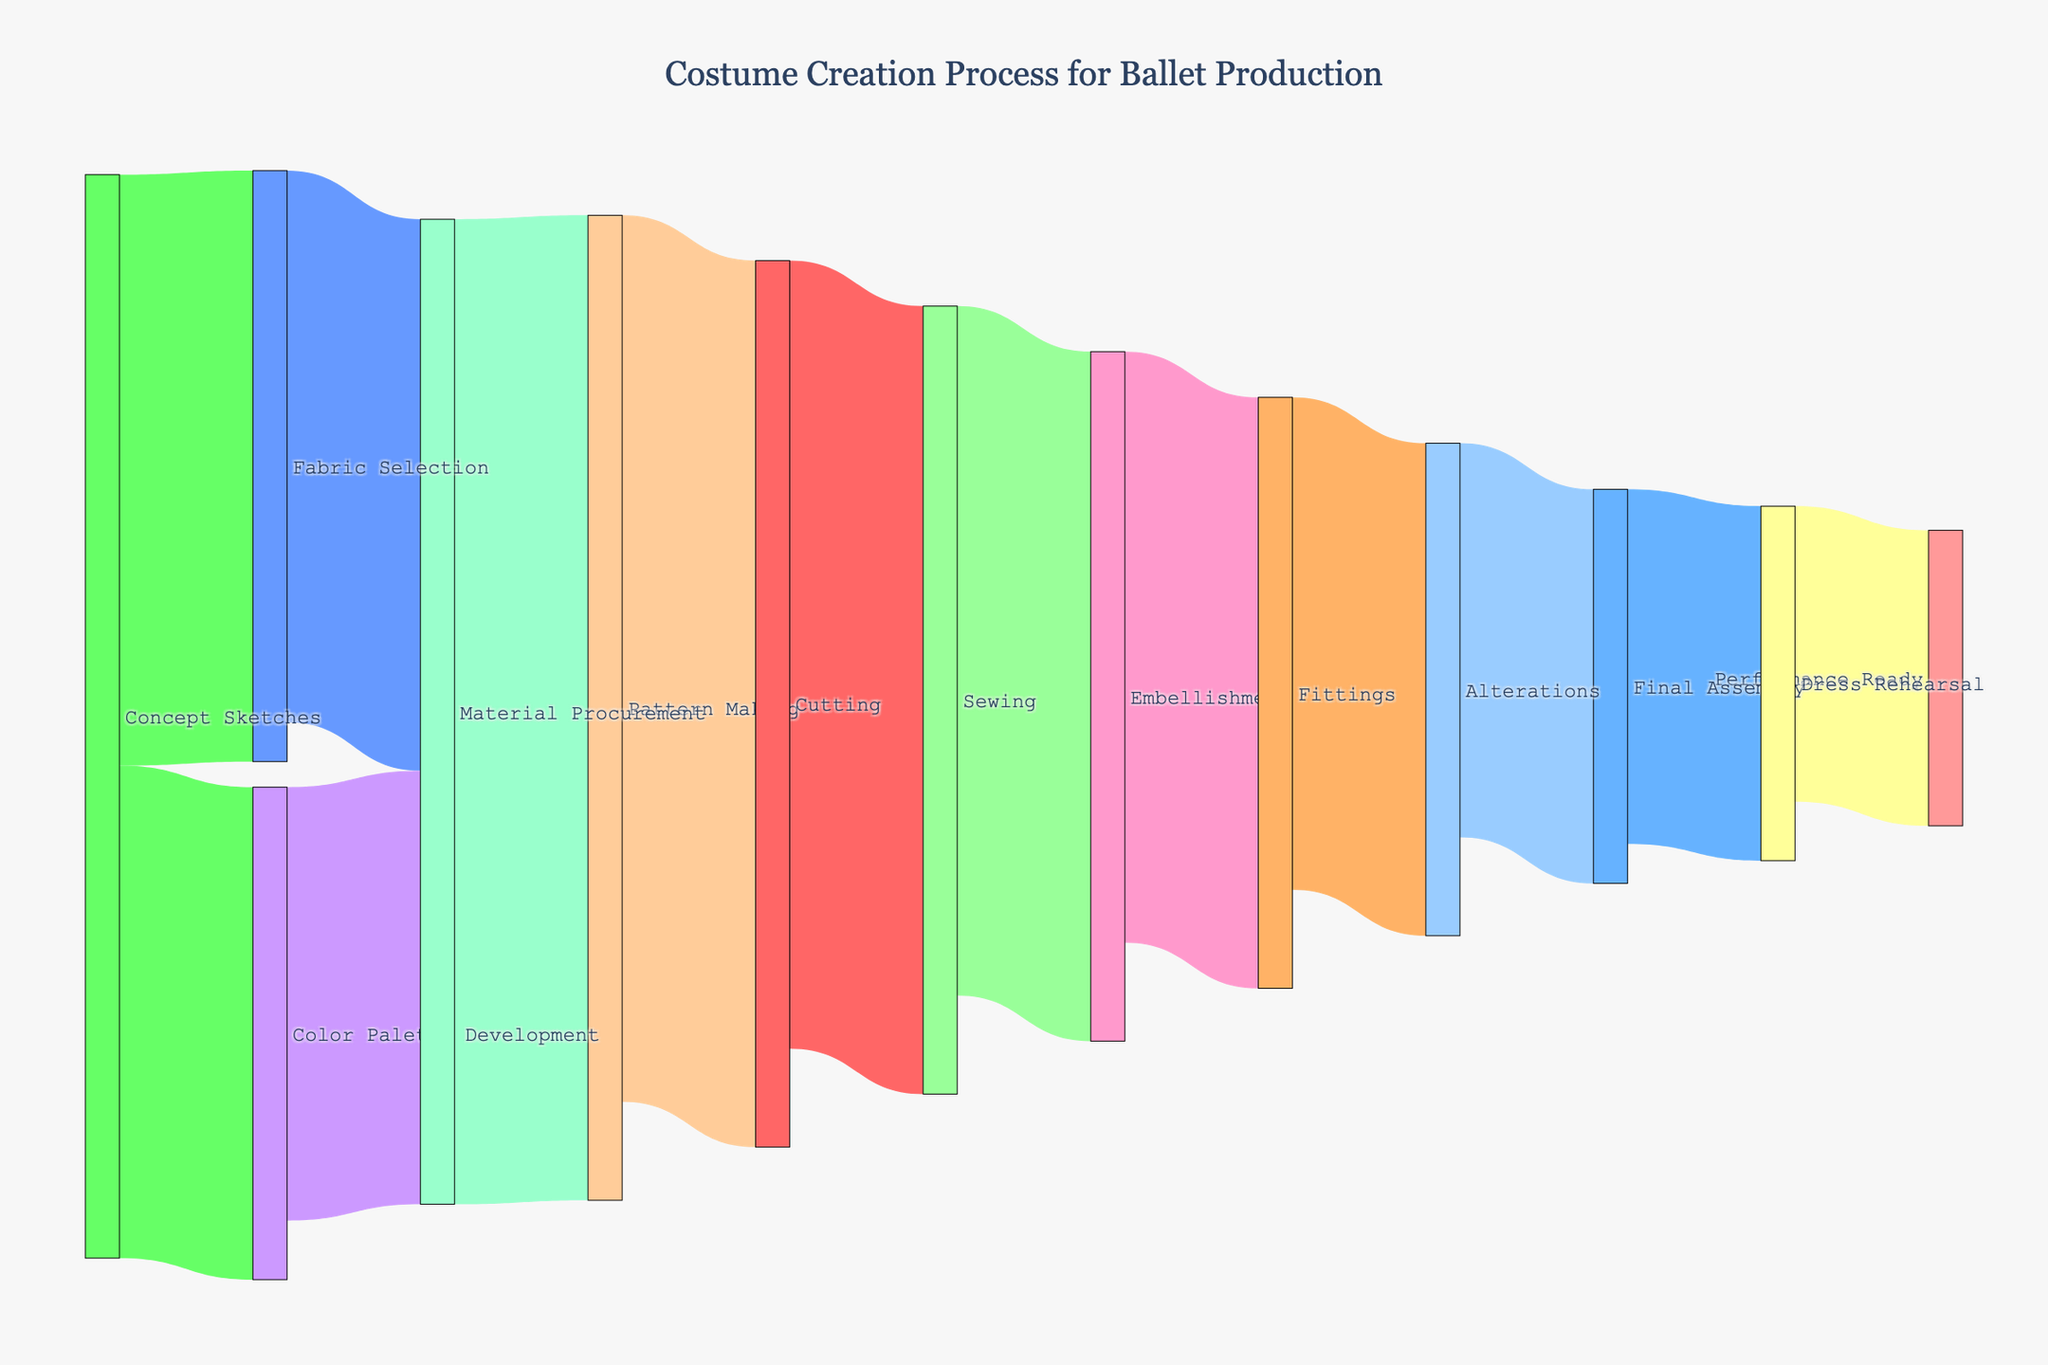What is the title of the Sankey diagram? The title of a Sankey diagram is usually displayed at the top of the figure. For this diagram, it clearly shows "Costume Creation Process for Ballet Production".
Answer: Costume Creation Process for Ballet Production Which two stages have the highest connections going out from them? By examining the width of the arrows extending from each node, it is evident that "Concept Sketches" and "Material Procurement" have the thickest flows indicating the highest number of connections going out.
Answer: Concept Sketches, Material Procurement What color are the nodes in the Sankey diagram? The nodes utilize a variety of vibrant colors which include shades of pink, blue, green, orange, etc.
Answer: Shades of pink, blue, green, orange, etc How many connections lead from "Pattern Making" and what are they? By observing the arrows from "Pattern Making", two connections can be seen leading to "Cutting" and "Sewing".
Answer: 1, Cutting Which stage has the most inputs, and what are they? To determine the stage with the most inputs, we look for the node with the most arrows pointing to it. "Material Procurement" has the most inputs from "Fabric Selection" and "Color Palette Development".
Answer: Material Procurement, Fabric Selection, Color Palette Development What is the smallest flow quantity and which stages does it link? The smallest flow quantity can be deduced by comparing the numbers on the arrows. The smallest is 15, linking "Dress Rehearsal" to "Performance Ready".
Answer: 15, Dress Rehearsal to Performance Ready If you sum up all the initial flow quantities from "Concept Sketches", what is the total? Adding up the flow quantities from "Concept Sketches", we have values 30 (to "Fabric Selection") and 25 (to "Color Palette Development"), which sum to 55.
Answer: 55 Which stage follows immediately after "Alterations"? By following the arrows from "Alterations", we see that it directly points to "Final Assembly".
Answer: Final Assembly Compare the flow from "Sewing" to both "Embellishment" and "Fittings", which is greater? Comparing the flow values from "Sewing" to "Embellishment" and to "Fittings", the value to "Embellishment" is 35, which is greater than 30 to "Fittings".
Answer: Embellishment How many stages are involved from the start of "Concept Sketches" to "Performance Ready"? Counting the stages from "Concept Sketches" to "Performance Ready", we have: Concept Sketches, Fabric Selection, Material Procurement, Pattern Making, Cutting, Sewing, Embellishment, Fittings, Alterations, Final Assembly, Dress Rehearsal, Performance Ready. Thus, there are 12 stages.
Answer: 12 